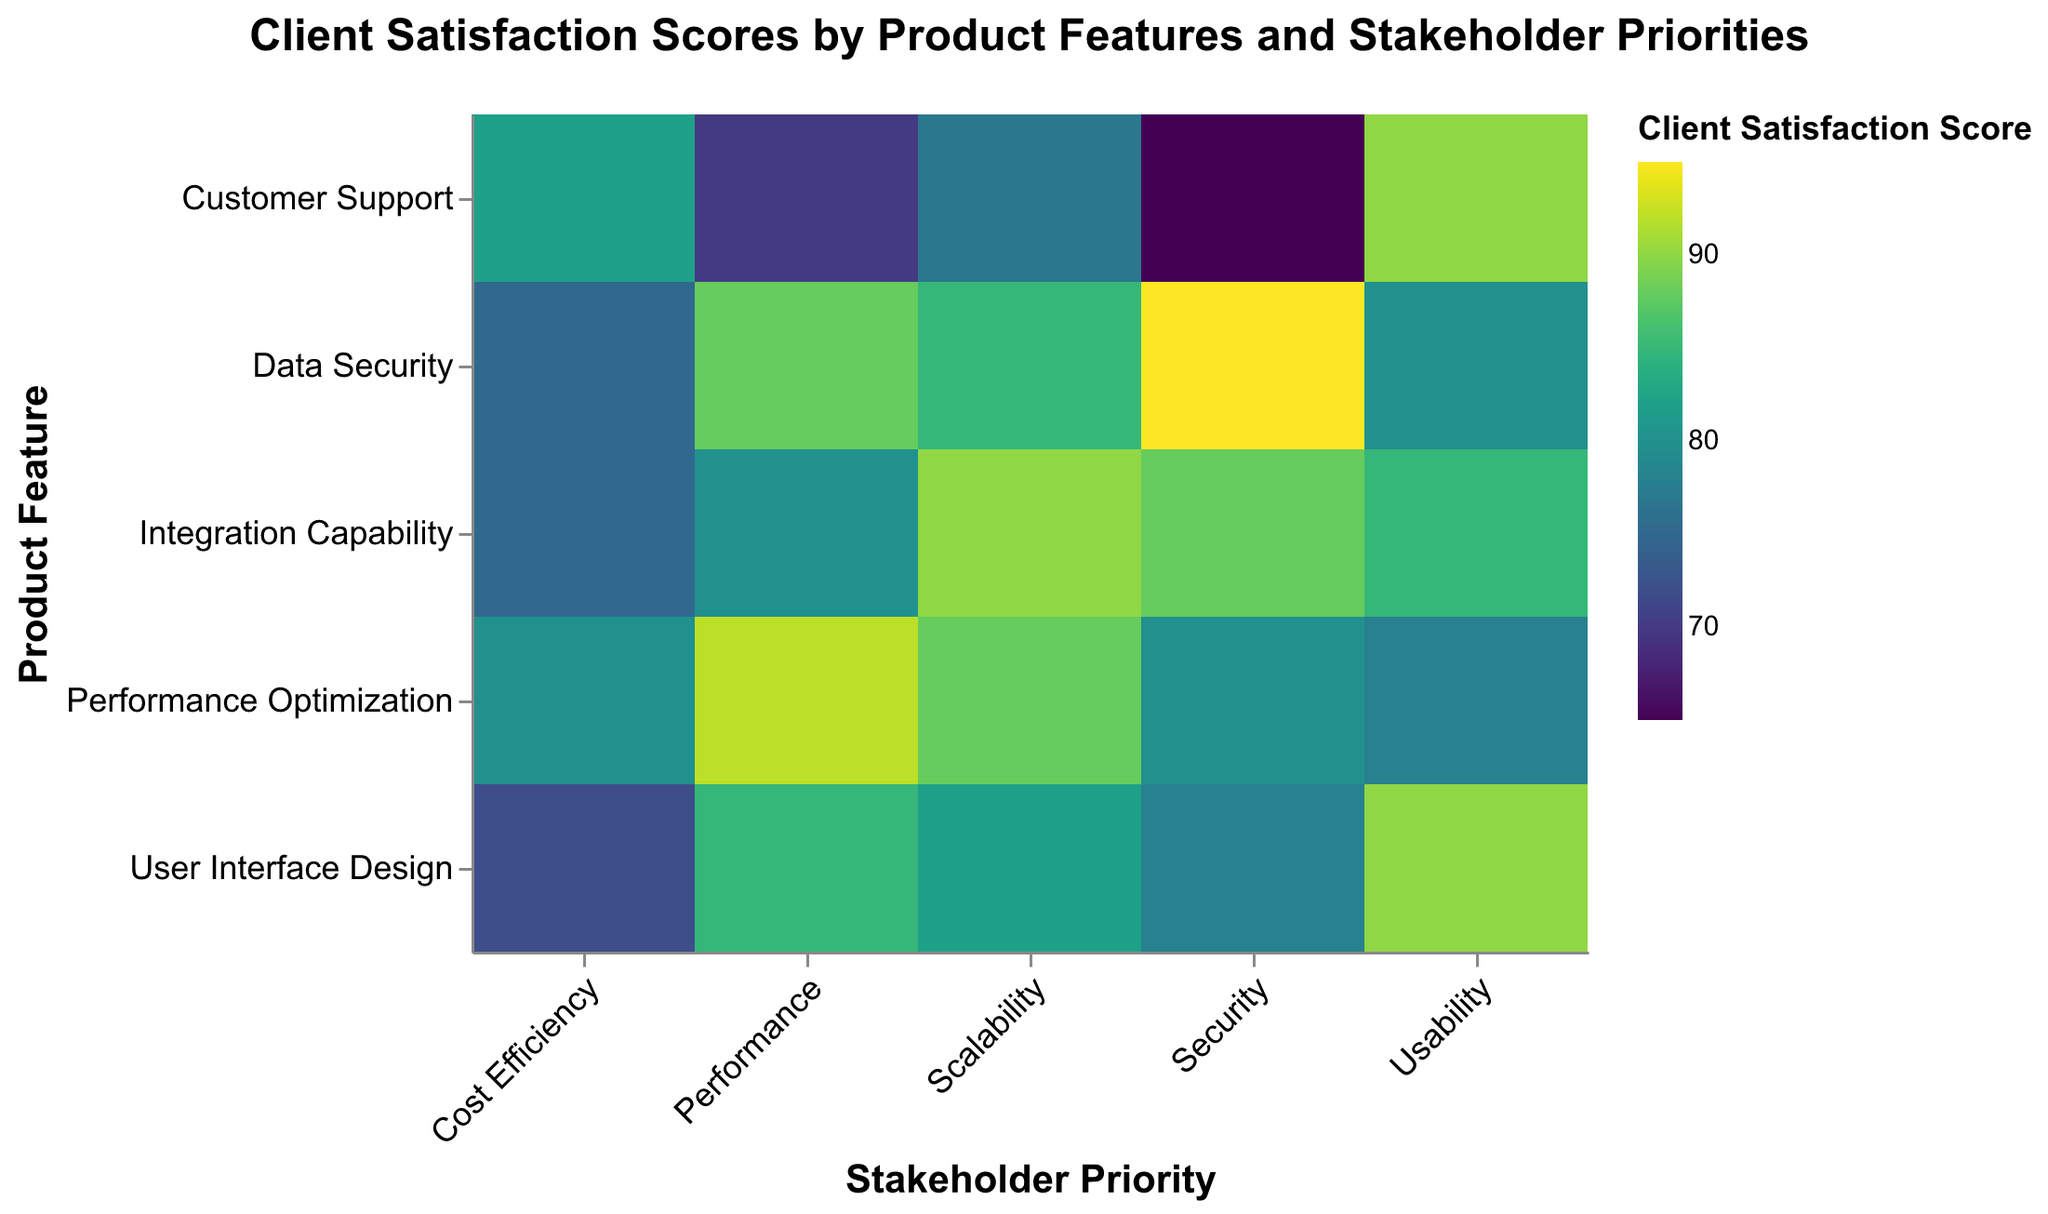What is the title of the heatmap? The title is located at the top center of the heatmap and is easily visible as it is prominently displayed.
Answer: Client Satisfaction Scores by Product Features and Stakeholder Priorities Which Product Feature has the highest Client Satisfaction Score for the "Security" priority? Look at the column for the "Security" priority and identify the highest score across all the rows for different Product Features.
Answer: Data Security How does the Client Satisfaction Score for "Customer Support" compare between "Performance" and "Usability"? Locate the row for "Customer Support" and compare the scores in the "Performance" and "Usability" columns.
Answer: "Usability" has a higher score (90) compared to "Performance" (70) Which Product Feature has the lowest Client Satisfaction Score overall? Traverse through all cells in the heatmap to identify the one with the lowest score.
Answer: Customer Support (Security) What is the average Client Satisfaction Score for the "User Interface Design" across all priorities? Sum up the scores for "User Interface Design" across all priorities and divide by the number of priorities: (85 + 78 + 90 + 72 + 82) / 5.
Answer: 81.4 Are there more Product Features with a Client Satisfaction Score above 80 for "Scalability" or for "Cost Efficiency"? Count the cells with scores above 80 for both "Scalability" and "Cost Efficiency" columns and compare.
Answer: Scalability Which Stakeholder Priority has the most consistent (least varied) Client Satisfaction Scores across Product Features? Calculate the variation (range or standard deviation) for the scores in each Stakeholder Priority column and identify the one with the least variation.
Answer: Usability Identify the Product Feature with the highest average satisfaction score across all Stakeholder Priorities Calculate the average score for each Product Feature across all Stakeholder Priorities and find the highest average value. Detailed steps include summing scores for each feature and dividing by the number of priorities (5).
Answer: Integration Capability How many Product Features have a Client Satisfaction Score of 90 or above for at least one Stakeholder Priority? Count the number of rows that have at least one cell with a score of 90 or above.
Answer: 4 